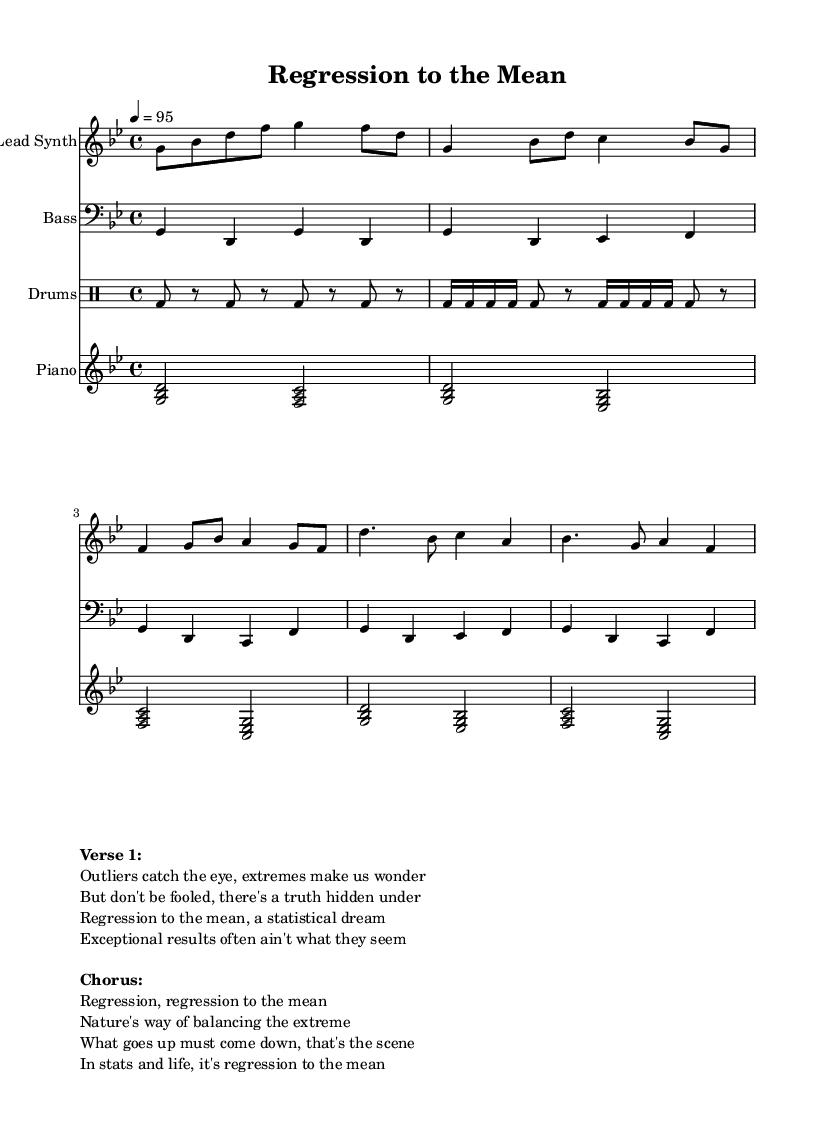What is the key signature of this music? The key signature is G minor, which contains two flats (B flat and E flat). This can be determined by examining the clef at the beginning of the staff and identifying the key signature alongside it.
Answer: G minor What is the time signature of this music? The time signature is 4/4, indicated at the beginning of the score. This means there are four beats in each measure, and the quarter note gets one beat.
Answer: 4/4 What is the tempo marking of this piece? The tempo marking is 95, specifying a metronomic speed of 95 beats per minute, established by the tempo indication at the beginning of the score.
Answer: 95 How many verses are in the lyrics provided? There is one verse in the lyrics contained in the markup. The format indicates a single verse followed by a chorus section, showing it as a single unit of lyrical content.
Answer: One What musical instrument plays the bass line? The instrument identified to play the bass line is a bass, as indicated at the start of the bass part, which is marked with “Bass.”
Answer: Bass Which statistical concept does the title refer to? The title refers to "Regression to the Mean," which is a statistical phenomenon where extreme values in a data set tend to be closer to the average on subsequent measurements. This title directly implies the theme explored in the lyrics.
Answer: Regression to the Mean What genre does this piece belong to? This piece belongs to the Hip Hop genre, as indicated by the overall style, lyrical content, and instrumentation typically associated with Hip Hop music.
Answer: Hip Hop 